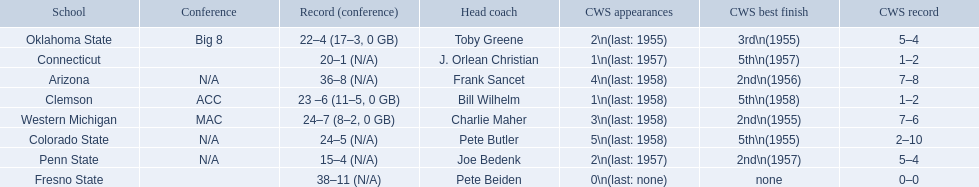How many cws appearances does clemson have? 1\n(last: 1958). How many cws appearances does western michigan have? 3\n(last: 1958). Which of these schools has more cws appearances? Western Michigan. 